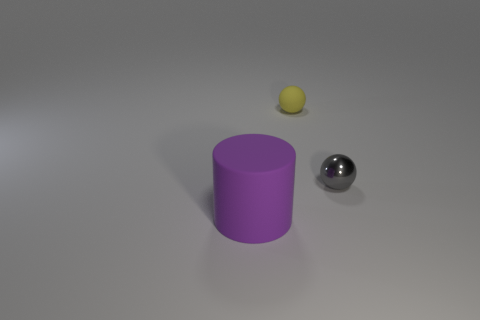Add 1 tiny shiny balls. How many objects exist? 4 Subtract all cylinders. How many objects are left? 2 Subtract 0 red balls. How many objects are left? 3 Subtract all big brown rubber cylinders. Subtract all tiny balls. How many objects are left? 1 Add 2 gray metallic balls. How many gray metallic balls are left? 3 Add 2 metal cubes. How many metal cubes exist? 2 